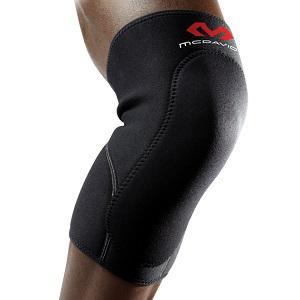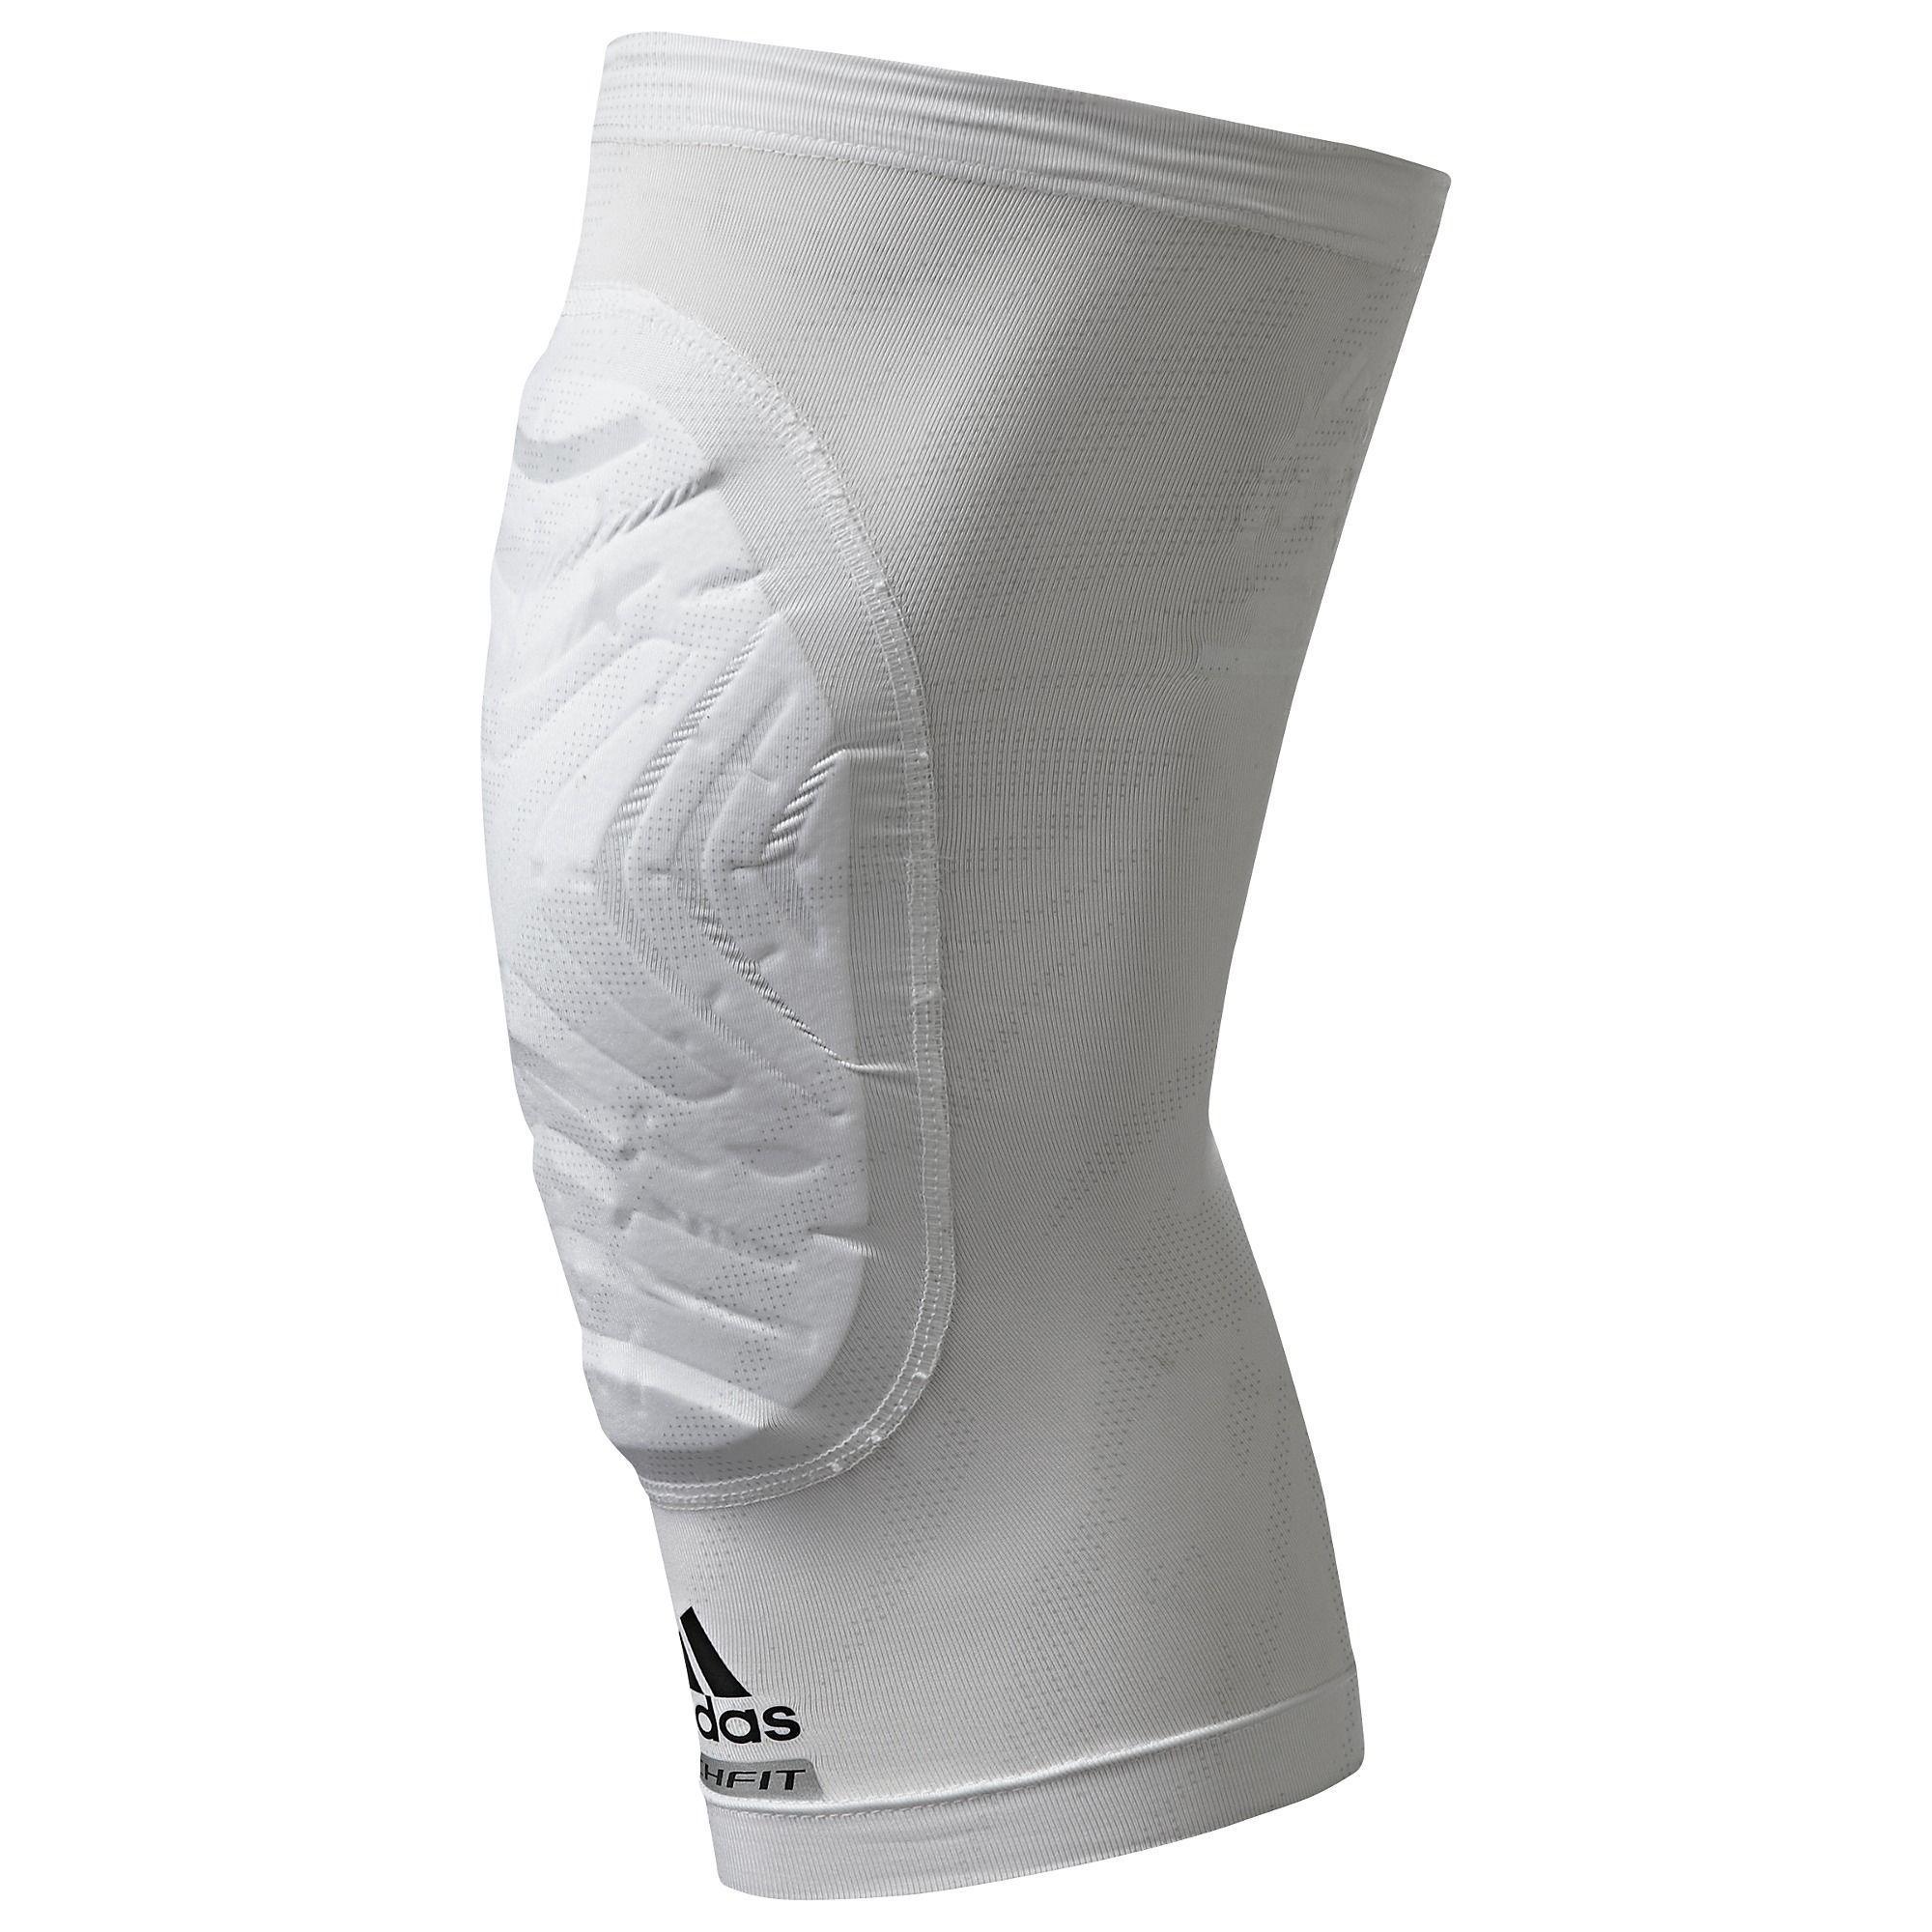The first image is the image on the left, the second image is the image on the right. Assess this claim about the two images: "The left image is one black brace, the right image is one white brace.". Correct or not? Answer yes or no. Yes. The first image is the image on the left, the second image is the image on the right. Examine the images to the left and right. Is the description "An image shows a pair of legs with one one leg wearing a knee wrap." accurate? Answer yes or no. No. 